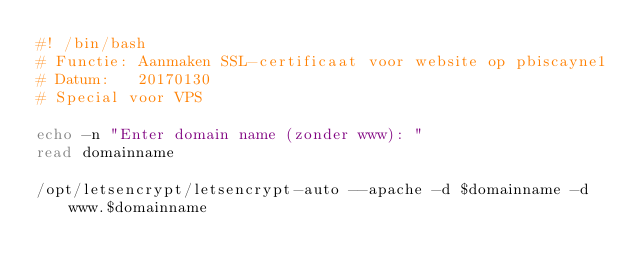Convert code to text. <code><loc_0><loc_0><loc_500><loc_500><_Bash_>#! /bin/bash
# Functie: Aanmaken SSL-certificaat voor website op pbiscayne1
# Datum:   20170130
# Special voor VPS

echo -n "Enter domain name (zonder www): "
read domainname

/opt/letsencrypt/letsencrypt-auto --apache -d $domainname -d www.$domainname
</code> 